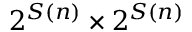Convert formula to latex. <formula><loc_0><loc_0><loc_500><loc_500>2 ^ { S ( n ) } \times 2 ^ { S ( n ) }</formula> 